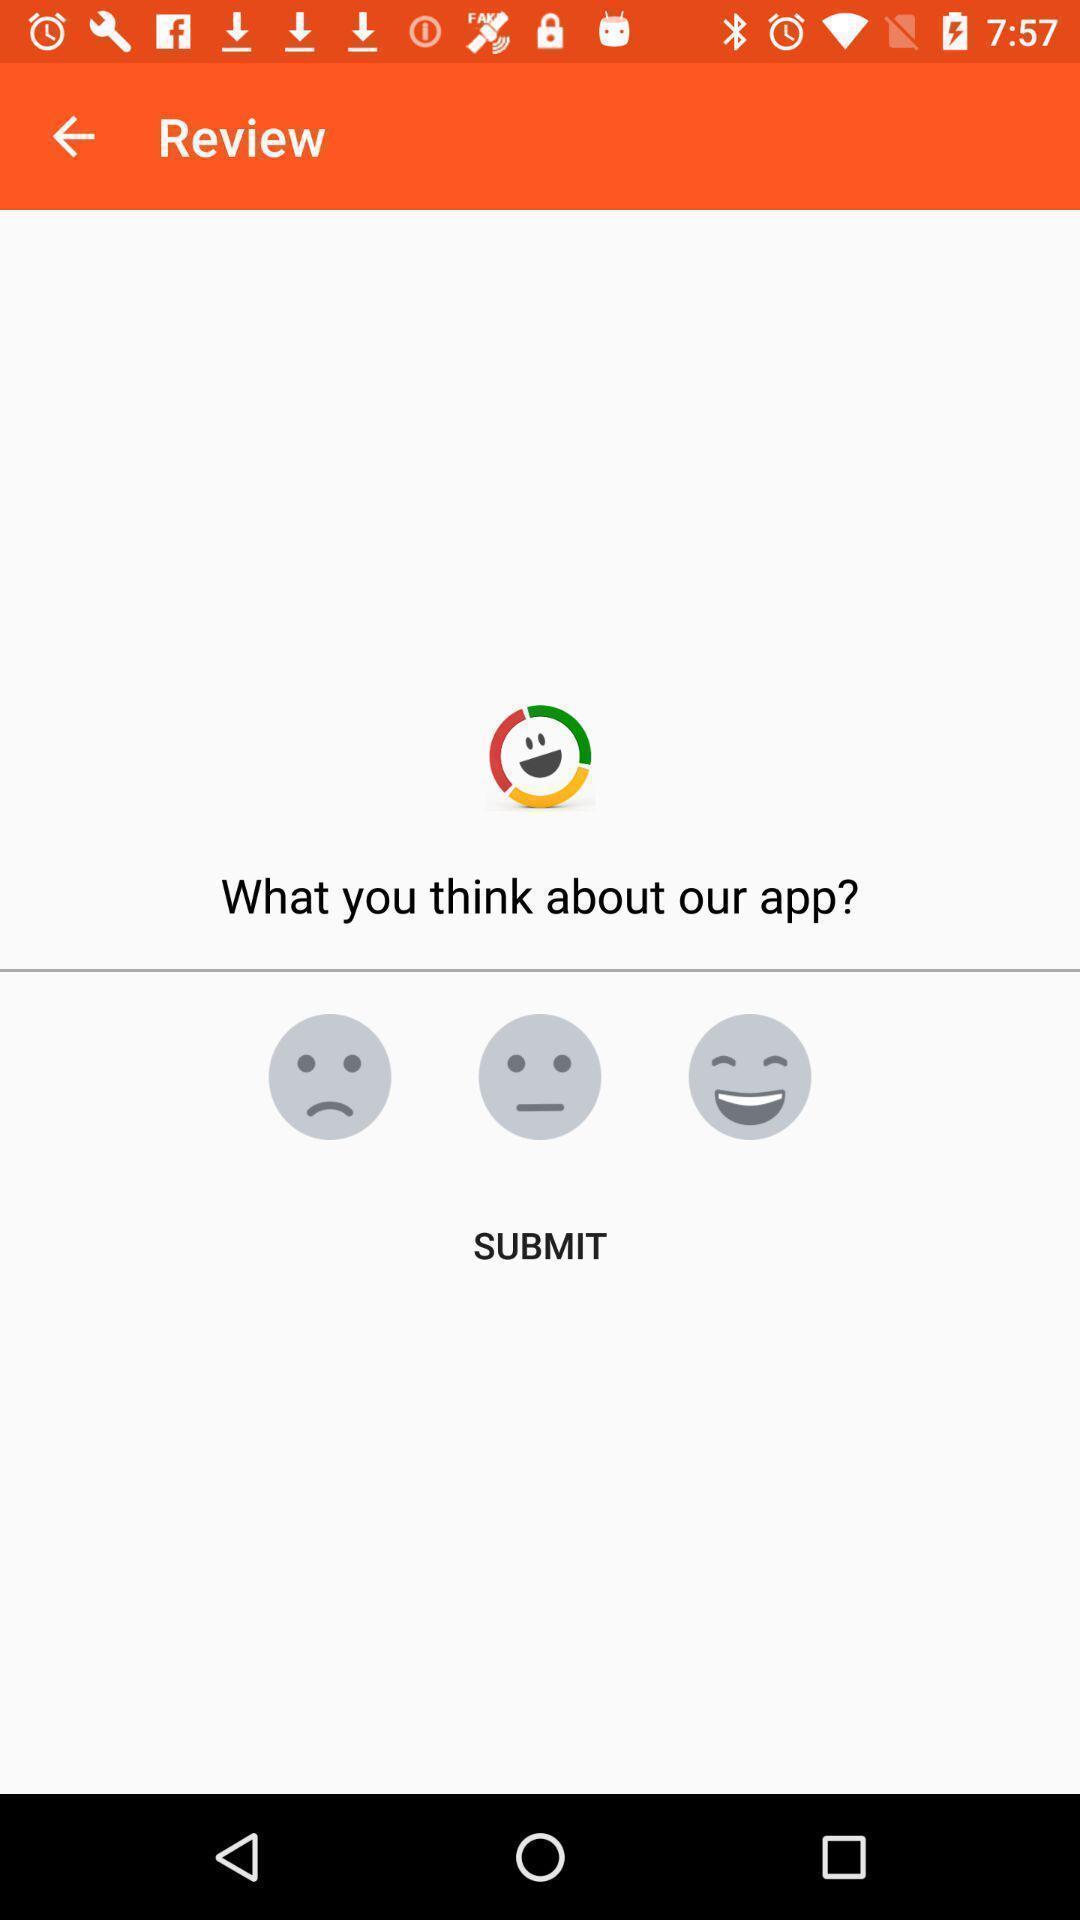Describe the key features of this screenshot. Screen displaying reviews page. 